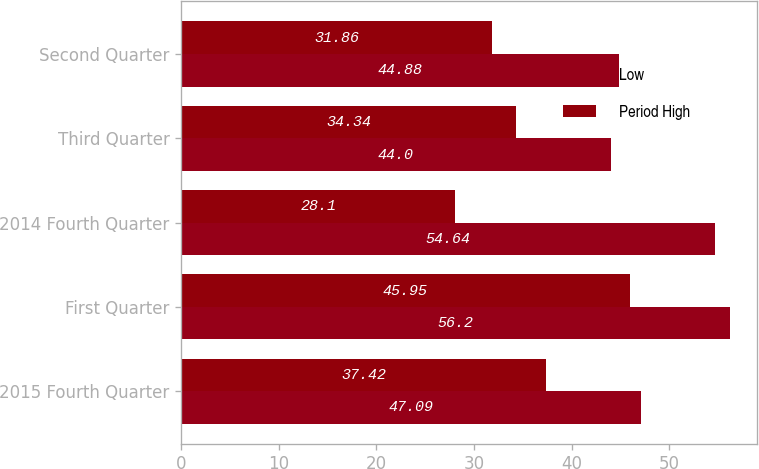Convert chart to OTSL. <chart><loc_0><loc_0><loc_500><loc_500><stacked_bar_chart><ecel><fcel>2015 Fourth Quarter<fcel>First Quarter<fcel>2014 Fourth Quarter<fcel>Third Quarter<fcel>Second Quarter<nl><fcel>Low<fcel>47.09<fcel>56.2<fcel>54.64<fcel>44<fcel>44.88<nl><fcel>Period High<fcel>37.42<fcel>45.95<fcel>28.1<fcel>34.34<fcel>31.86<nl></chart> 